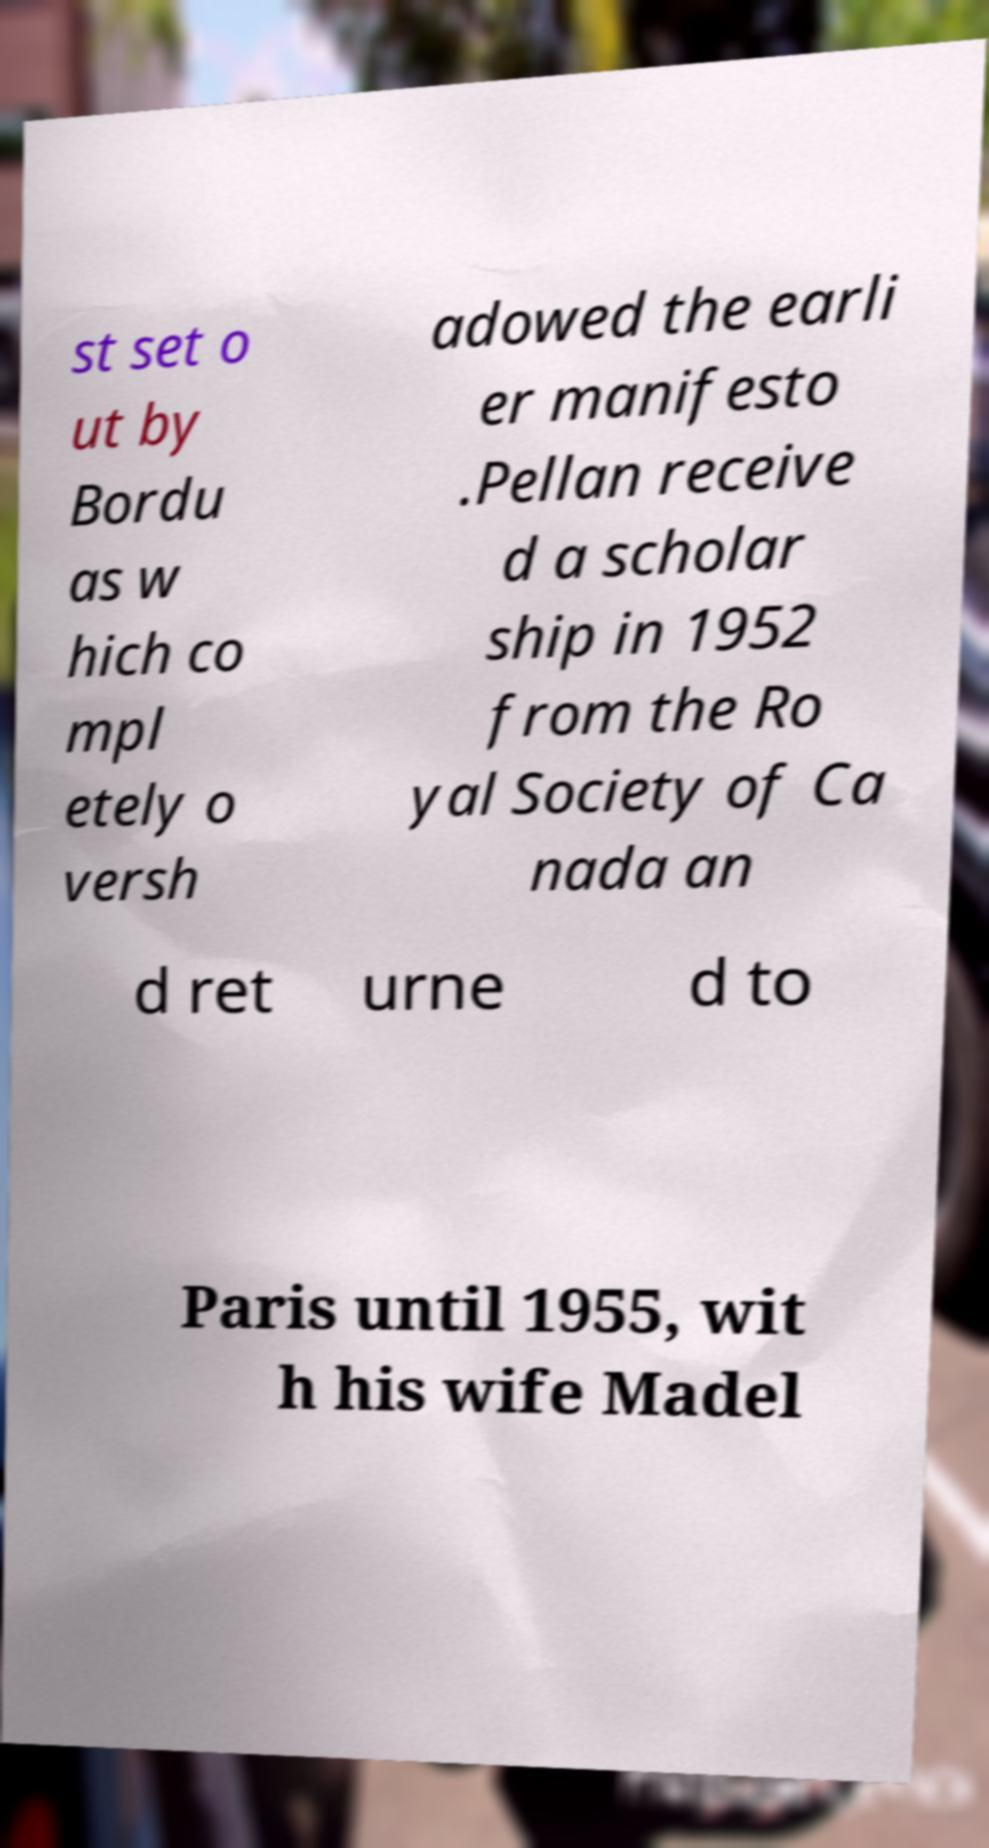For documentation purposes, I need the text within this image transcribed. Could you provide that? st set o ut by Bordu as w hich co mpl etely o versh adowed the earli er manifesto .Pellan receive d a scholar ship in 1952 from the Ro yal Society of Ca nada an d ret urne d to Paris until 1955, wit h his wife Madel 